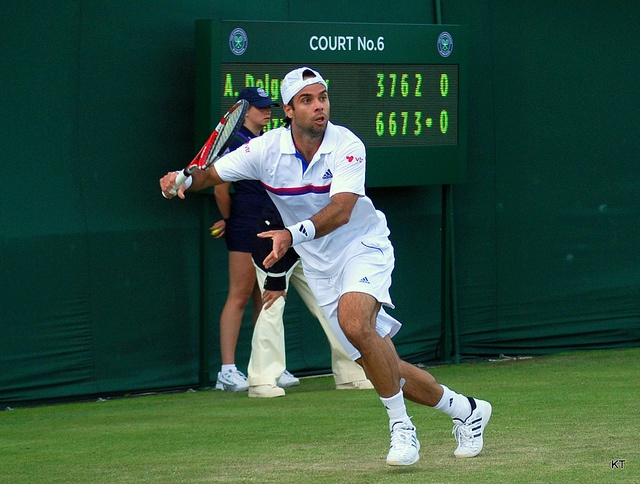Describe the objects in this image and their specific colors. I can see people in black, lightgray, darkgray, brown, and lightblue tones, people in black, brown, and maroon tones, tennis racket in black, darkgray, gray, and red tones, and sports ball in black, lime, green, olive, and yellow tones in this image. 